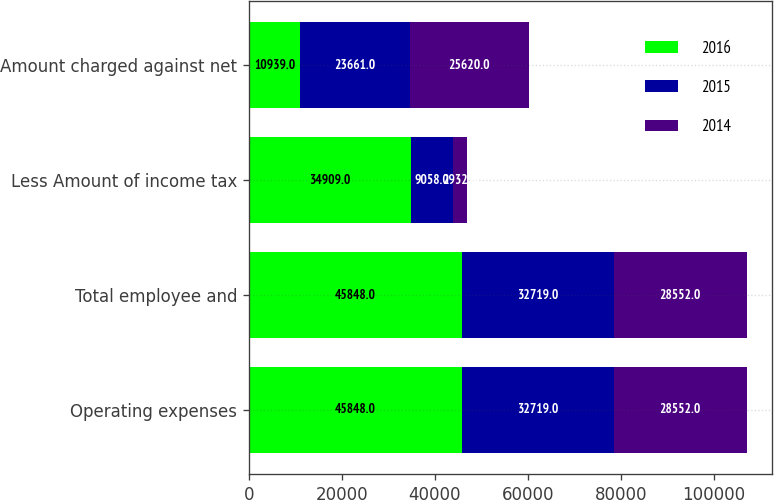Convert chart. <chart><loc_0><loc_0><loc_500><loc_500><stacked_bar_chart><ecel><fcel>Operating expenses<fcel>Total employee and<fcel>Less Amount of income tax<fcel>Amount charged against net<nl><fcel>2016<fcel>45848<fcel>45848<fcel>34909<fcel>10939<nl><fcel>2015<fcel>32719<fcel>32719<fcel>9058<fcel>23661<nl><fcel>2014<fcel>28552<fcel>28552<fcel>2932<fcel>25620<nl></chart> 